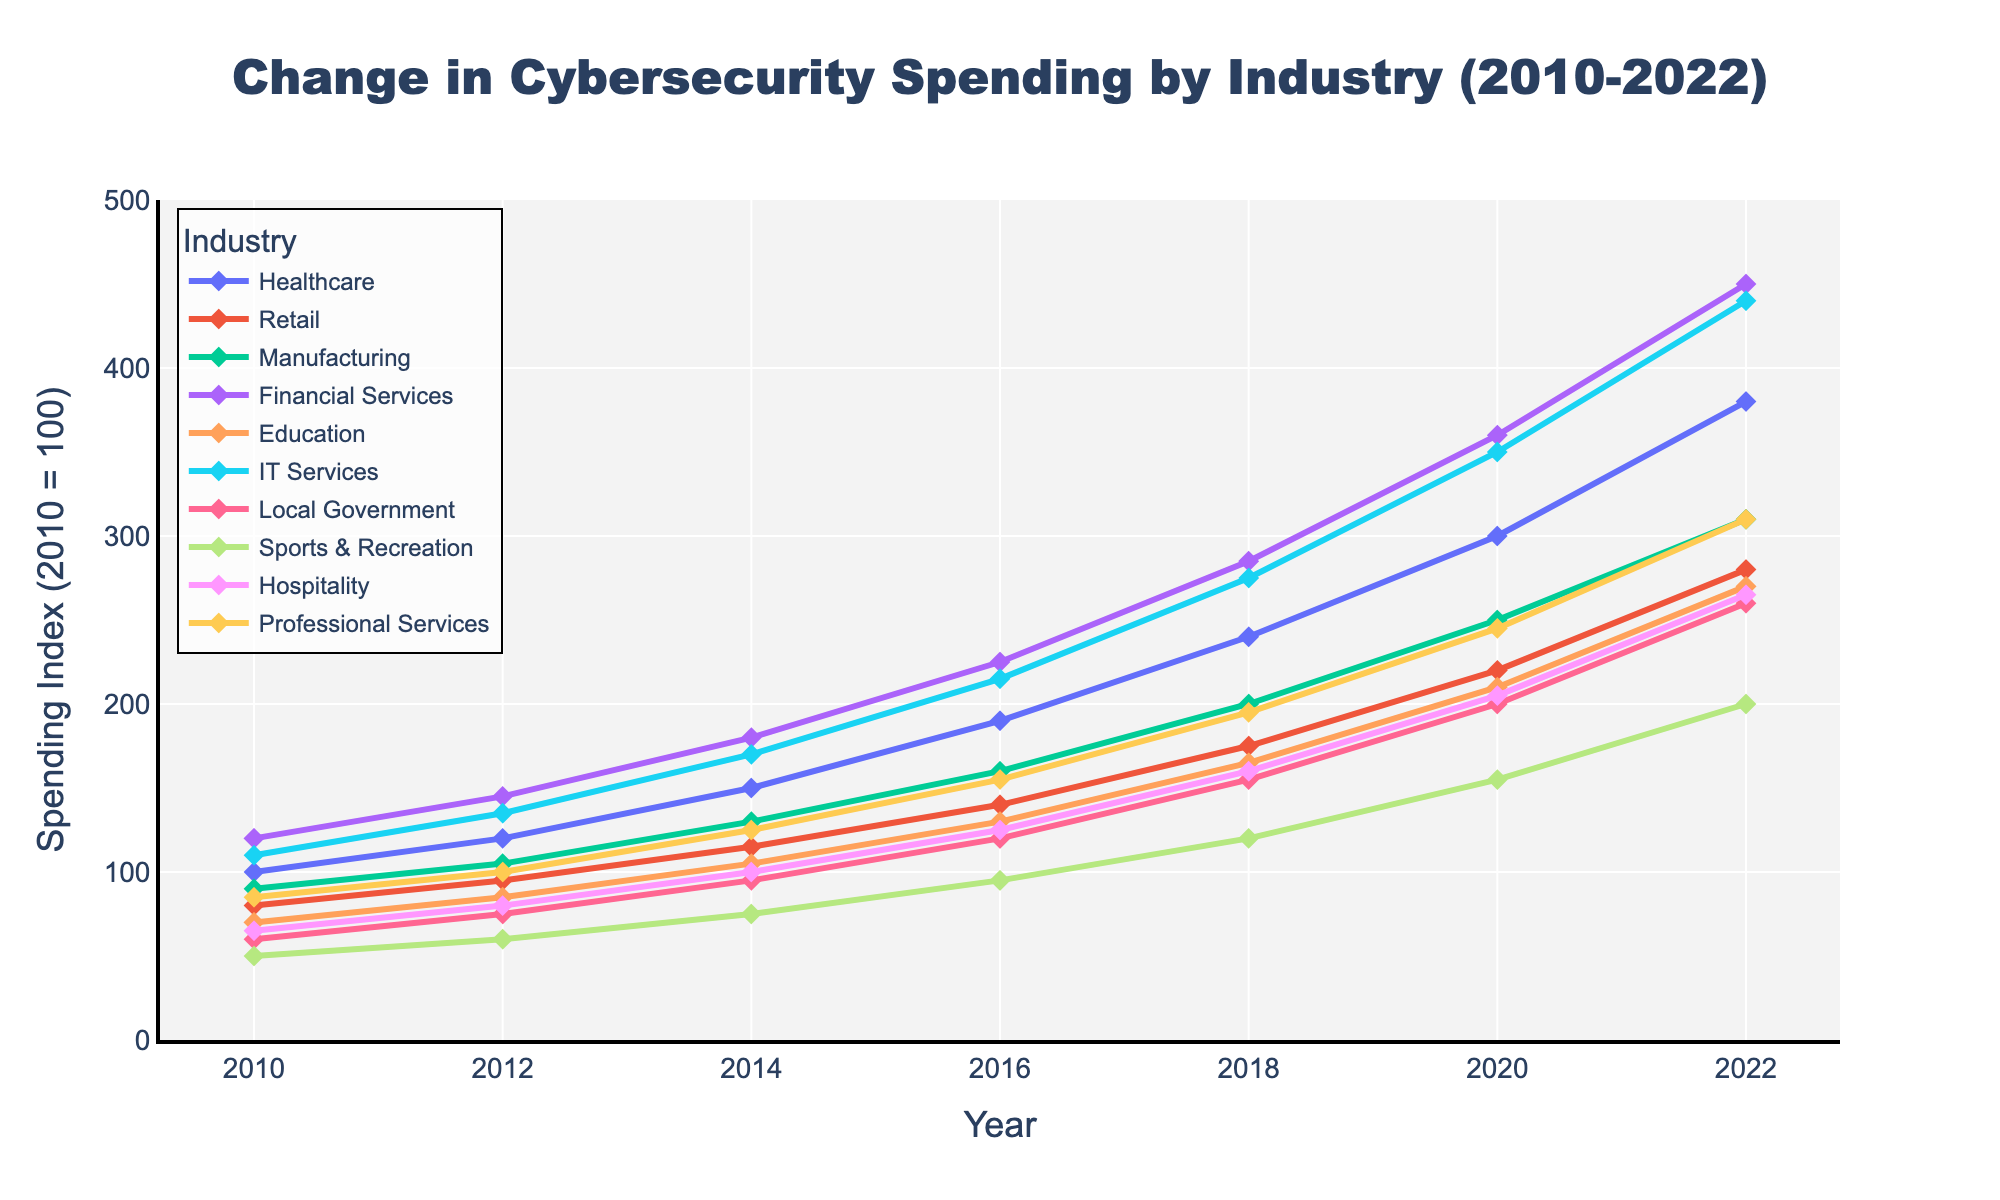What is the industry with the highest increase in cybersecurity spending from 2010 to 2022? First, observe the starting point in 2010 and the ending point in 2022 for all industries. Financial Services starts at 120 and ends at 450, which is the highest increase among all industries.
Answer: Financial Services Which industry saw the least increase in cybersecurity spending between 2010 and 2022? Find the industry with the smallest difference between 2010 and 2022 spending values. Sports & Recreation starts at 50 and ends at 200, showing the least increase.
Answer: Sports & Recreation By how much did Local Government's cybersecurity spending increase from 2010 to 2022? Look at the spending for Local Government in 2010 and in 2022. The spending increased from 60 to 260. Calculate the increase: 260 - 60.
Answer: 200 Which industry had the highest spending in 2018 and how much was it? Check the 2018 spending values for all industries and identify the highest one. Financial Services had the highest spending in 2018, which was 285.
Answer: Financial Services, 285 Which two industries had the closest spending in 2020, and what were their values? Compare the 2020 values for all industries and find the two with the smallest difference. Healthcare and IT Services both had very similar values, with Healthcare at 300 and IT Services at 350, having a difference of 50, but Manufacturing and Professional Services are closer, both around 245 and 250.
Answer: Manufacturing (250) and Professional Services (245) Calculate the average spending across all industries in 2022. Sum all the spending values for 2022 and divide by the number of industries (10). (380 + 280 + 310 + 450 + 270 + 440 + 260 + 200 + 265 + 310) / 10 = 3165 / 10 = 316.5.
Answer: 316.5 In which year did Retail's cybersecurity spending surpass 100 for the first time? Look at the Retail spending values year by year. The spending surpasses 100 between 2012 and 2014.
Answer: 2014 Which year shows the sharpest increase in cybersecurity spending for IT Services? Look at the spending values for IT Services between each year to identify the largest difference between consecutive years. The largest jump is from 2018 (275) to 2020 (350).
Answer: 2018-2020 How much did Healthcare's spending grow between 2016 and 2020? Identify Healthcare's spending in 2016 and 2020. The values are 190 and 300, respectively. Calculate the growth: 300 - 190.
Answer: 110 Compare the cybersecurity spending of Education and Local Government in 2018. Which one is higher? Look at the spending values for both industries in 2018. Education is 165, while Local Government is 155. So, Education is higher.
Answer: Education 